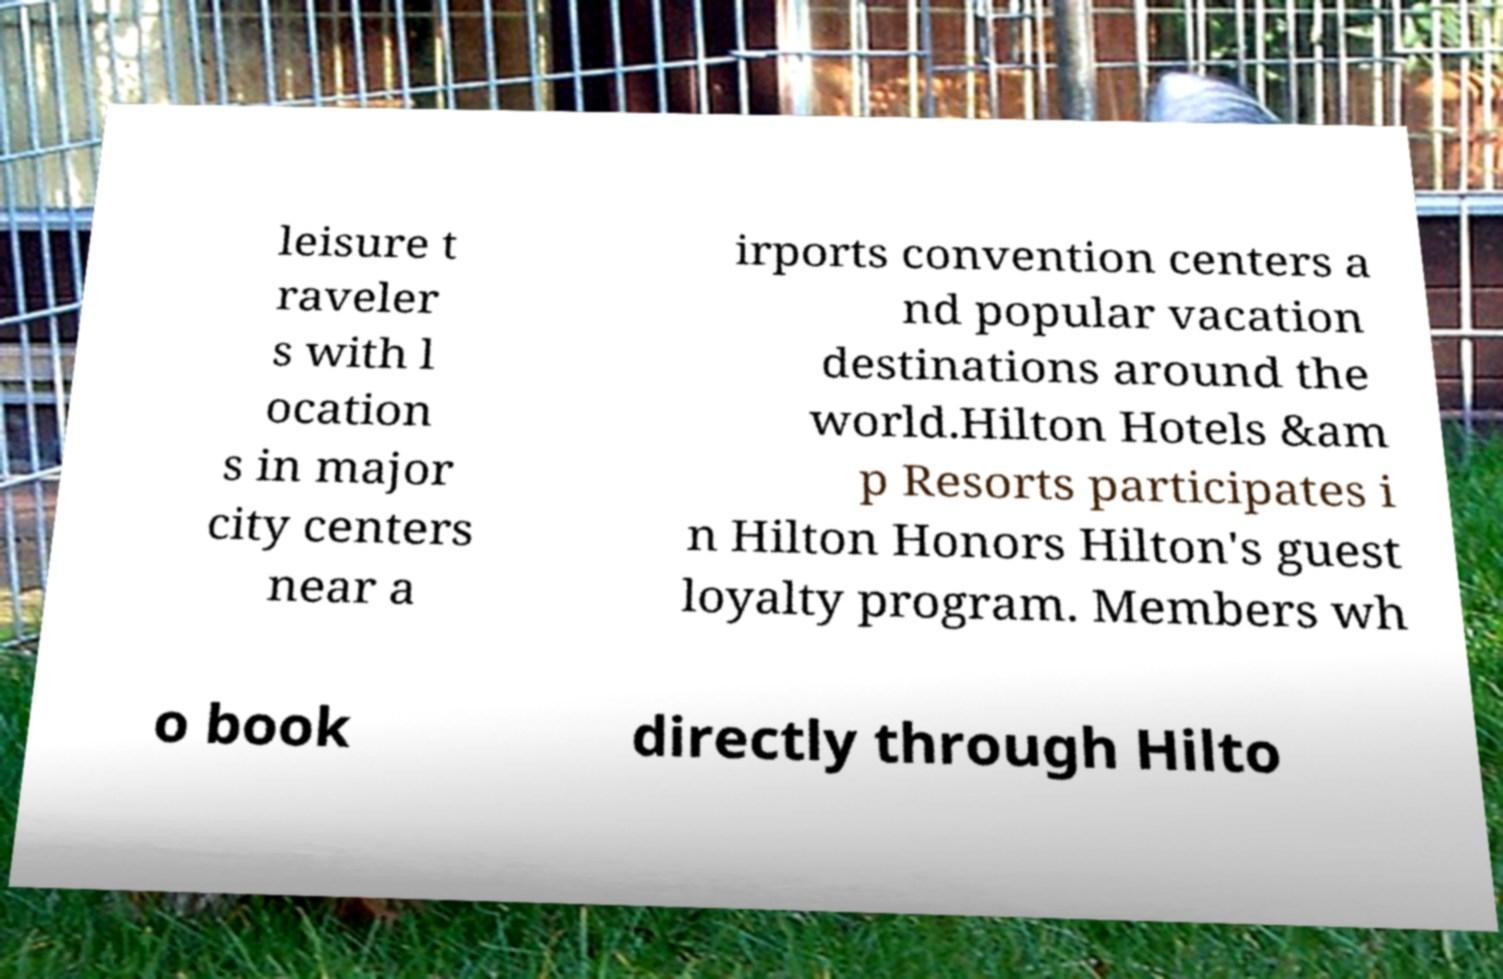There's text embedded in this image that I need extracted. Can you transcribe it verbatim? leisure t raveler s with l ocation s in major city centers near a irports convention centers a nd popular vacation destinations around the world.Hilton Hotels &am p Resorts participates i n Hilton Honors Hilton's guest loyalty program. Members wh o book directly through Hilto 